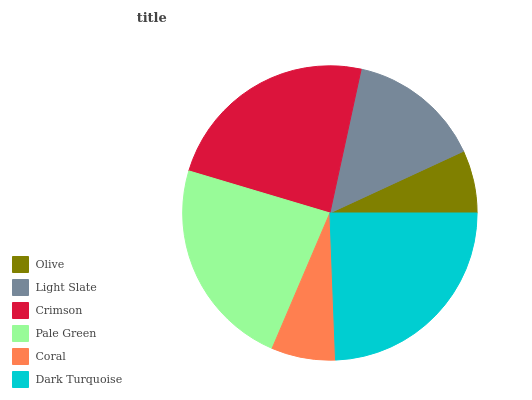Is Olive the minimum?
Answer yes or no. Yes. Is Dark Turquoise the maximum?
Answer yes or no. Yes. Is Light Slate the minimum?
Answer yes or no. No. Is Light Slate the maximum?
Answer yes or no. No. Is Light Slate greater than Olive?
Answer yes or no. Yes. Is Olive less than Light Slate?
Answer yes or no. Yes. Is Olive greater than Light Slate?
Answer yes or no. No. Is Light Slate less than Olive?
Answer yes or no. No. Is Pale Green the high median?
Answer yes or no. Yes. Is Light Slate the low median?
Answer yes or no. Yes. Is Dark Turquoise the high median?
Answer yes or no. No. Is Crimson the low median?
Answer yes or no. No. 